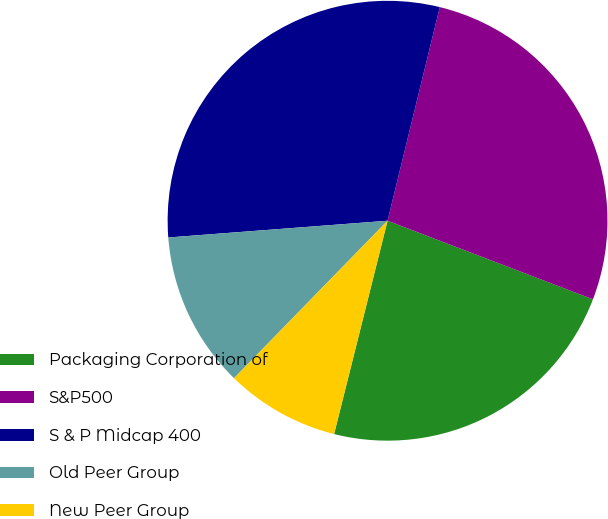Convert chart. <chart><loc_0><loc_0><loc_500><loc_500><pie_chart><fcel>Packaging Corporation of<fcel>S&P500<fcel>S & P Midcap 400<fcel>Old Peer Group<fcel>New Peer Group<nl><fcel>23.09%<fcel>27.0%<fcel>30.03%<fcel>11.49%<fcel>8.39%<nl></chart> 